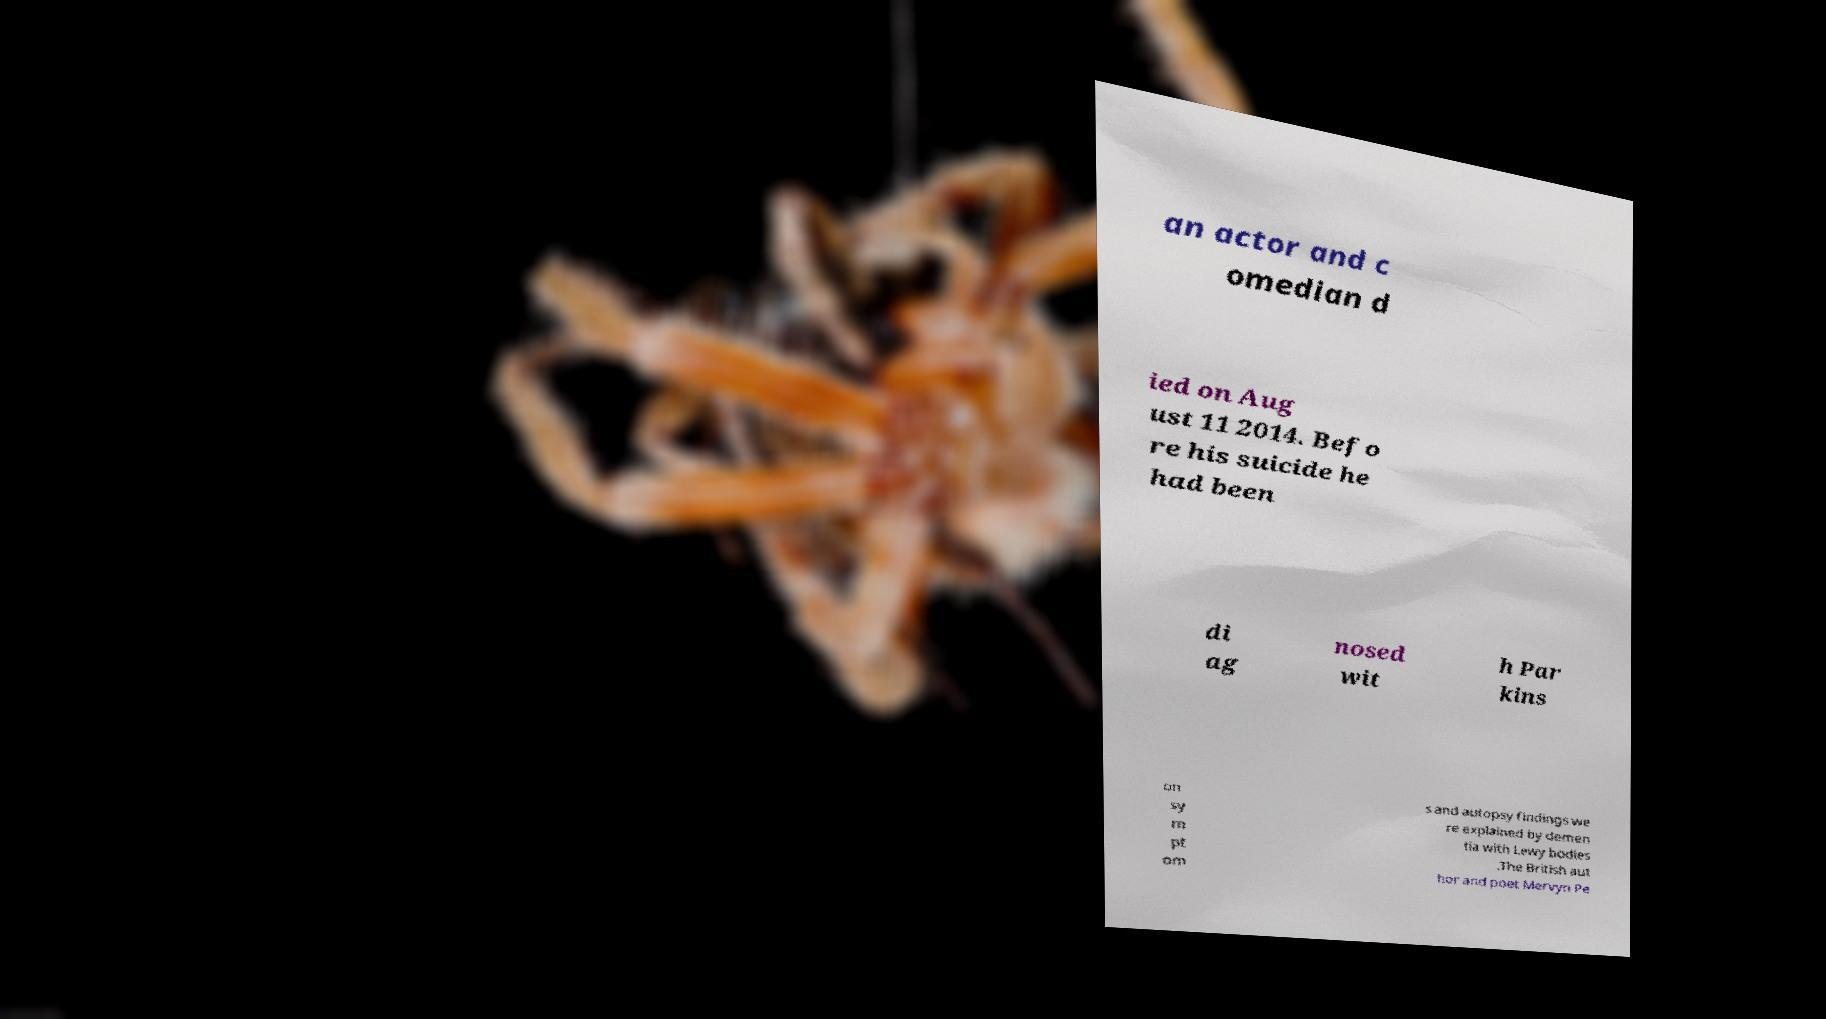Could you assist in decoding the text presented in this image and type it out clearly? an actor and c omedian d ied on Aug ust 11 2014. Befo re his suicide he had been di ag nosed wit h Par kins on sy m pt om s and autopsy findings we re explained by demen tia with Lewy bodies .The British aut hor and poet Mervyn Pe 